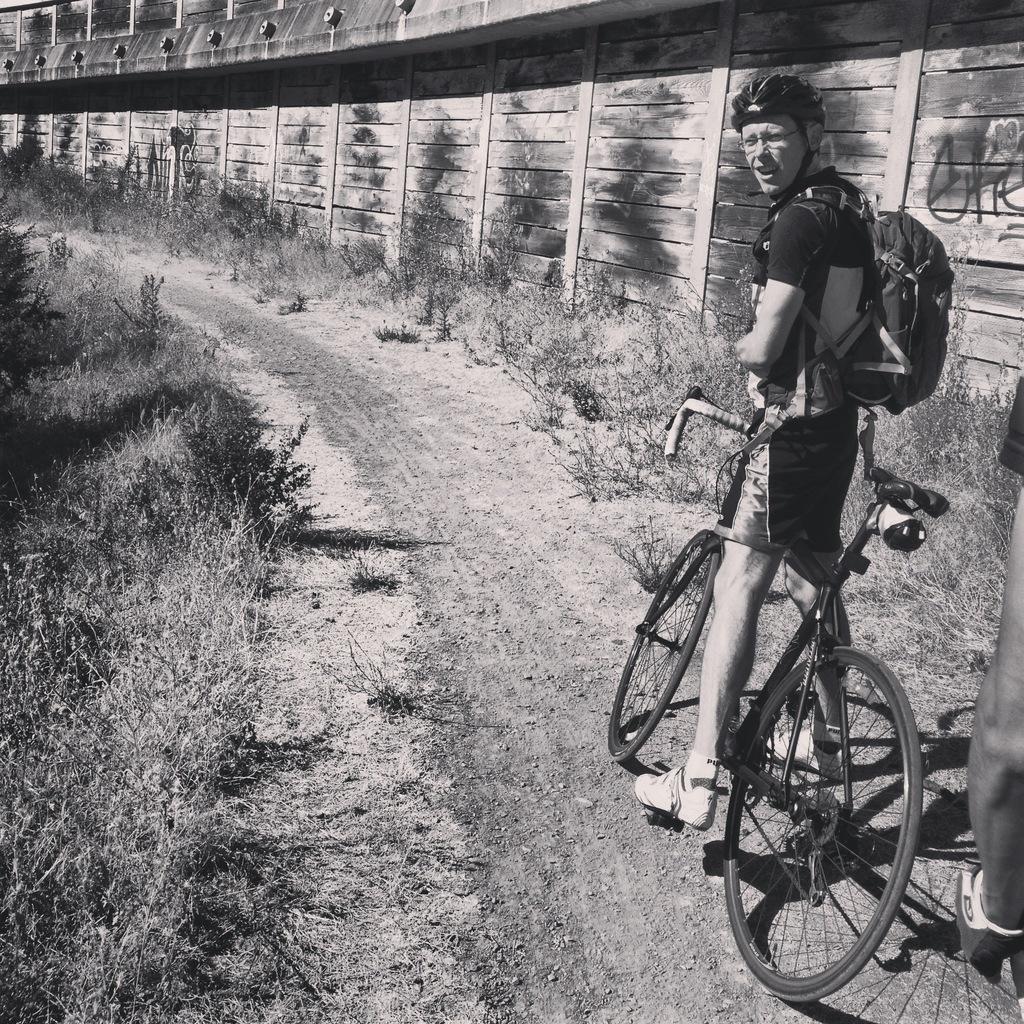In one or two sentences, can you explain what this image depicts? In this image on the right, there is a man, he wears a t shirt, trouser, shoes, bag and helmet, he is riding a bicycle, behind him there is a person. In the middle there are plants, grassland and wall. 